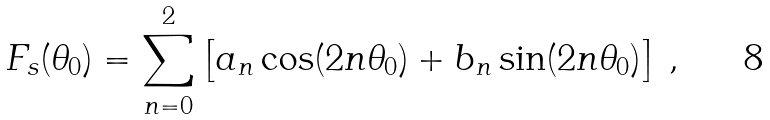Convert formula to latex. <formula><loc_0><loc_0><loc_500><loc_500>F _ { s } ( \theta _ { 0 } ) = \sum _ { n = 0 } ^ { 2 } \left [ a _ { n } \cos ( 2 n \theta _ { 0 } ) + b _ { n } \sin ( 2 n \theta _ { 0 } ) \right ] \, ,</formula> 